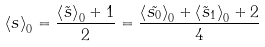Convert formula to latex. <formula><loc_0><loc_0><loc_500><loc_500>\left < s \right > _ { 0 } = \frac { \left < \tilde { s } \right > _ { 0 } + 1 } { 2 } = \frac { \left < \tilde { s _ { 0 } } \right > _ { 0 } + \left < \tilde { s } _ { 1 } \right > _ { 0 } + 2 } { 4 }</formula> 